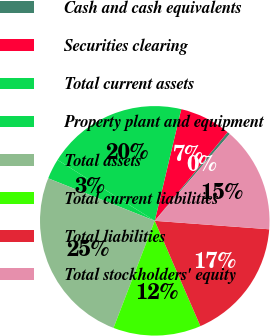Convert chart to OTSL. <chart><loc_0><loc_0><loc_500><loc_500><pie_chart><fcel>Cash and cash equivalents<fcel>Securities clearing<fcel>Total current assets<fcel>Property plant and equipment<fcel>Total assets<fcel>Total current liabilities<fcel>Total liabilities<fcel>Total stockholders' equity<nl><fcel>0.39%<fcel>7.24%<fcel>19.8%<fcel>2.87%<fcel>25.19%<fcel>12.36%<fcel>17.32%<fcel>14.84%<nl></chart> 